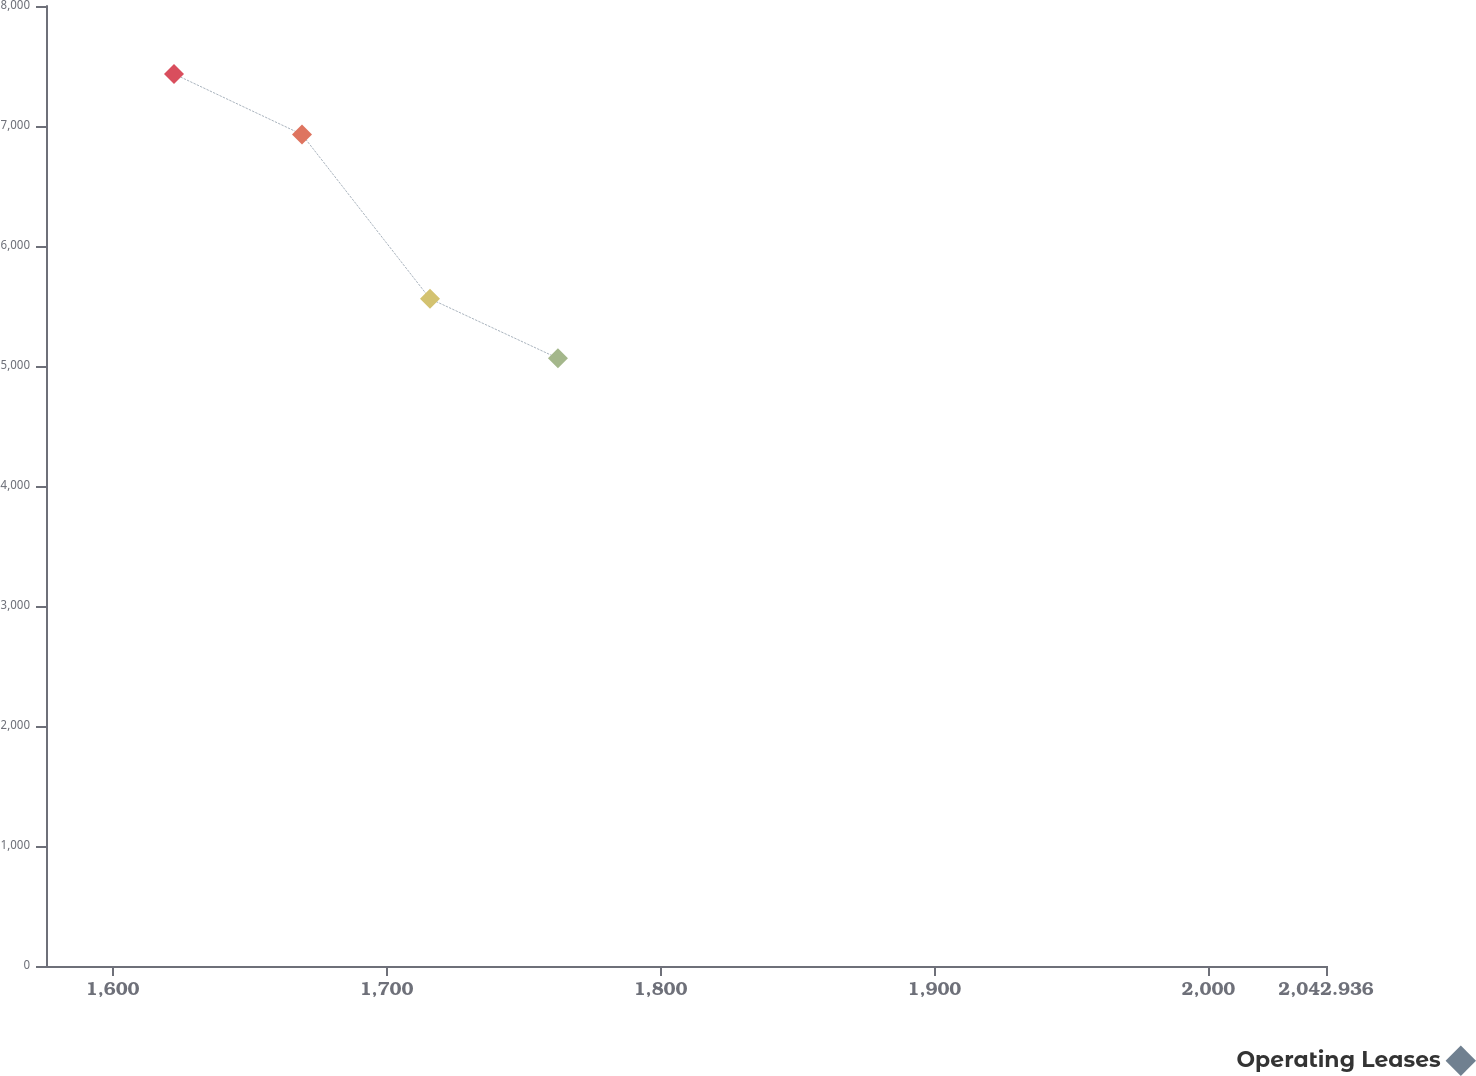Convert chart. <chart><loc_0><loc_0><loc_500><loc_500><line_chart><ecel><fcel>Operating Leases<nl><fcel>1622.42<fcel>7433.84<nl><fcel>1669.14<fcel>6929.26<nl><fcel>1715.86<fcel>5560.86<nl><fcel>1762.58<fcel>5064.16<nl><fcel>2089.66<fcel>4179.97<nl></chart> 